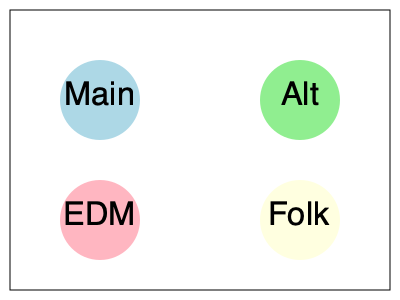You're organizing an inclusive music festival in a rectangular space measuring 80m by 60m. You plan to set up four stages: Main, Alternative, EDM, and Folk, each requiring a circular area with a 20m diameter. If you want to maximize the distance between the centers of the stages while keeping them within the festival grounds, what is the minimum distance (in meters) between the centers of any two adjacent stages? To solve this problem, we need to follow these steps:

1) First, let's visualize the optimal layout. The most efficient way to maximize distance between stages is to place them in the corners of the rectangular space.

2) The festival space dimensions are 80m x 60m. Each stage requires a circular area with a 20m diameter, which means a 10m radius.

3) To ensure the stages are fully within the festival grounds, we need to place their centers 10m away from the edges of the rectangle.

4) This leaves us with an inner rectangle where the stage centers can be placed:
   Width: $80m - (2 * 10m) = 60m$
   Height: $60m - (2 * 10m) = 40m$

5) The stage centers will be at the corners of this 60m x 40m rectangle.

6) To find the minimum distance between adjacent stages, we need to calculate:
   a) The horizontal distance: $60m$
   b) The vertical distance: $40m$

7) The shorter of these two is the minimum distance between adjacent stages: 40m.

This layout ensures maximum spacing between stages while accommodating all four within the festival grounds, promoting an inclusive environment where different music genres have equal prominence.
Answer: 40m 